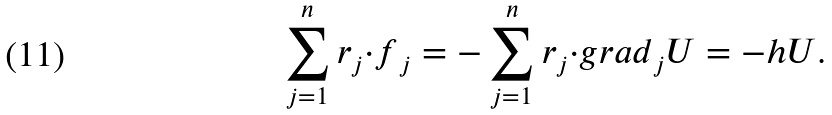<formula> <loc_0><loc_0><loc_500><loc_500>\sum _ { j = 1 } ^ { n } { r } _ { j } { \cdot f } _ { j } = - \sum _ { j = 1 } ^ { n } { r } _ { j } { \cdot g r a d } _ { j } U = - h U .</formula> 